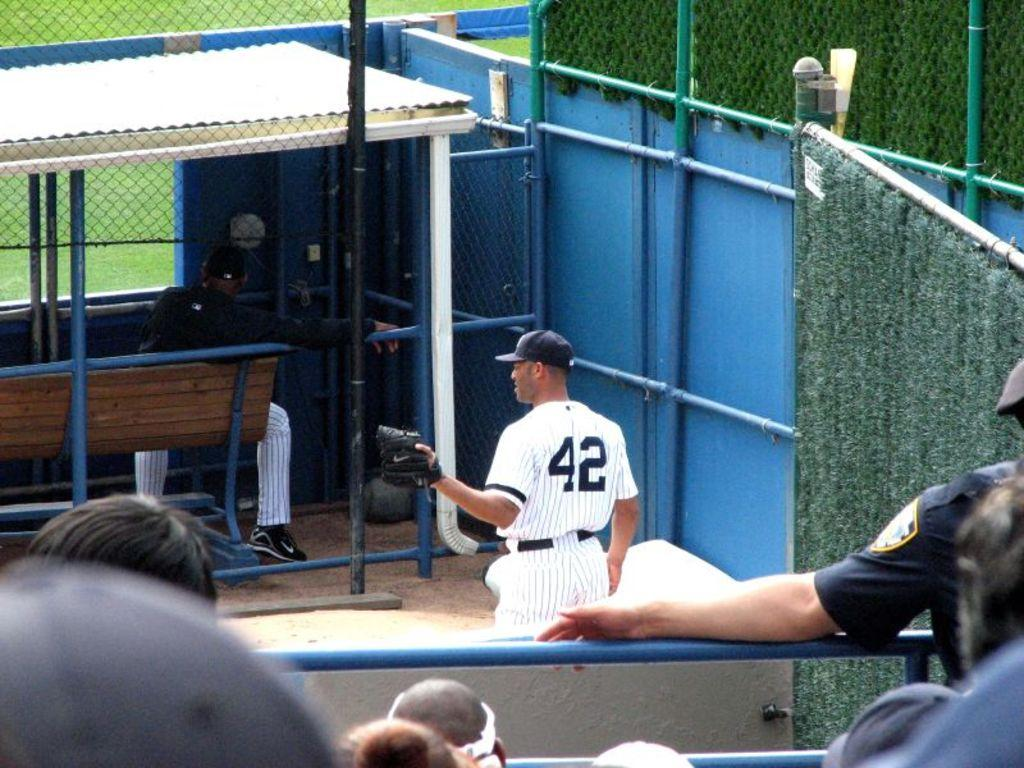<image>
Summarize the visual content of the image. A baseball game with the number 42 player in the shot 